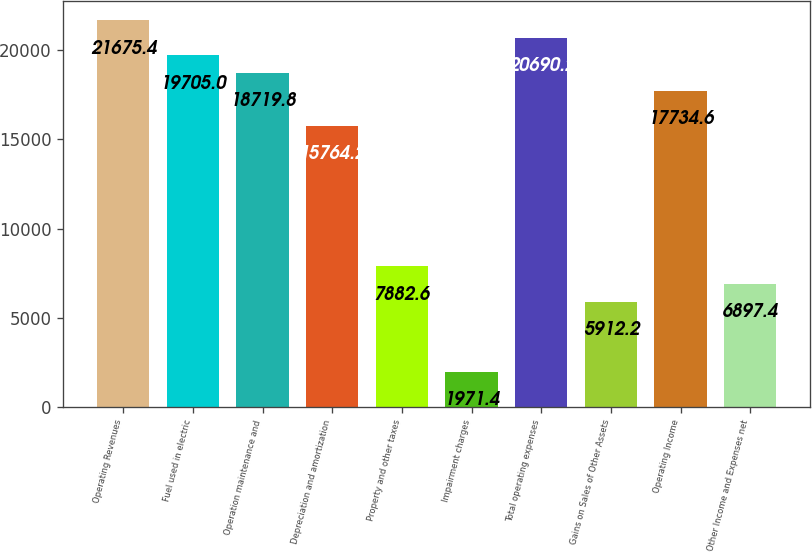<chart> <loc_0><loc_0><loc_500><loc_500><bar_chart><fcel>Operating Revenues<fcel>Fuel used in electric<fcel>Operation maintenance and<fcel>Depreciation and amortization<fcel>Property and other taxes<fcel>Impairment charges<fcel>Total operating expenses<fcel>Gains on Sales of Other Assets<fcel>Operating Income<fcel>Other Income and Expenses net<nl><fcel>21675.4<fcel>19705<fcel>18719.8<fcel>15764.2<fcel>7882.6<fcel>1971.4<fcel>20690.2<fcel>5912.2<fcel>17734.6<fcel>6897.4<nl></chart> 